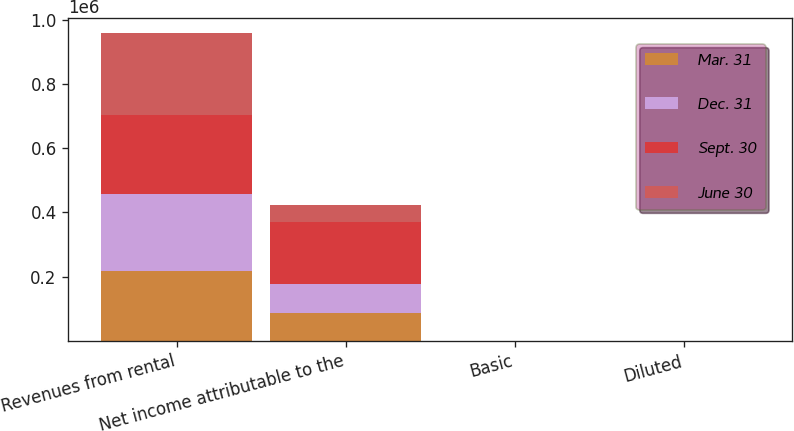Convert chart to OTSL. <chart><loc_0><loc_0><loc_500><loc_500><stacked_bar_chart><ecel><fcel>Revenues from rental<fcel>Net income attributable to the<fcel>Basic<fcel>Diluted<nl><fcel>Mar. 31<fcel>219152<fcel>87000<fcel>0.18<fcel>0.18<nl><fcel>Dec. 31<fcel>237432<fcel>89512<fcel>0.18<fcel>0.18<nl><fcel>Sept. 30<fcel>246555<fcel>194708<fcel>0.44<fcel>0.44<nl><fcel>June 30<fcel>255749<fcel>52781<fcel>0.09<fcel>0.09<nl></chart> 